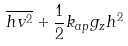<formula> <loc_0><loc_0><loc_500><loc_500>\overline { h v ^ { 2 } } + \frac { 1 } { 2 } k _ { a p } g _ { z } h ^ { 2 }</formula> 